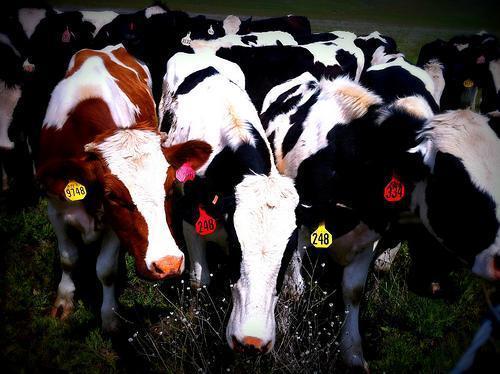How many red tags are on the cows?
Give a very brief answer. 3. How many yellow tags are there?
Give a very brief answer. 2. 